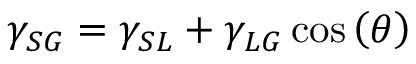<formula> <loc_0><loc_0><loc_500><loc_500>\gamma _ { S G } = \gamma _ { S L } + \gamma _ { L G } \cos \left ( \theta \right )</formula> 